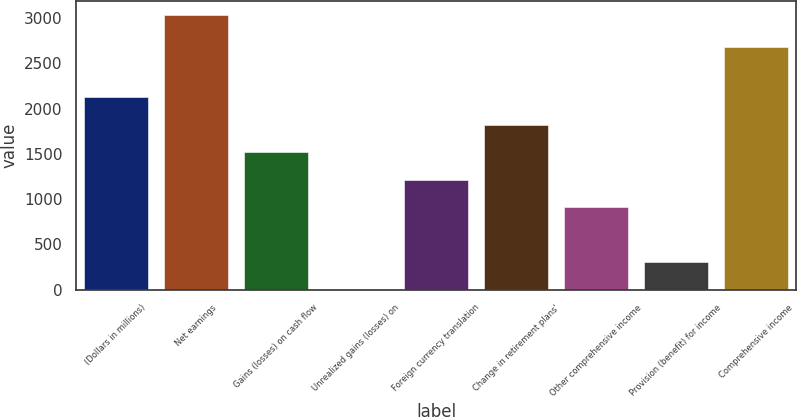Convert chart. <chart><loc_0><loc_0><loc_500><loc_500><bar_chart><fcel>(Dollars in millions)<fcel>Net earnings<fcel>Gains (losses) on cash flow<fcel>Unrealized gains (losses) on<fcel>Foreign currency translation<fcel>Change in retirement plans'<fcel>Other comprehensive income<fcel>Provision (benefit) for income<fcel>Comprehensive income<nl><fcel>2125.8<fcel>3036<fcel>1519<fcel>2<fcel>1215.6<fcel>1822.4<fcel>912.2<fcel>305.4<fcel>2685<nl></chart> 